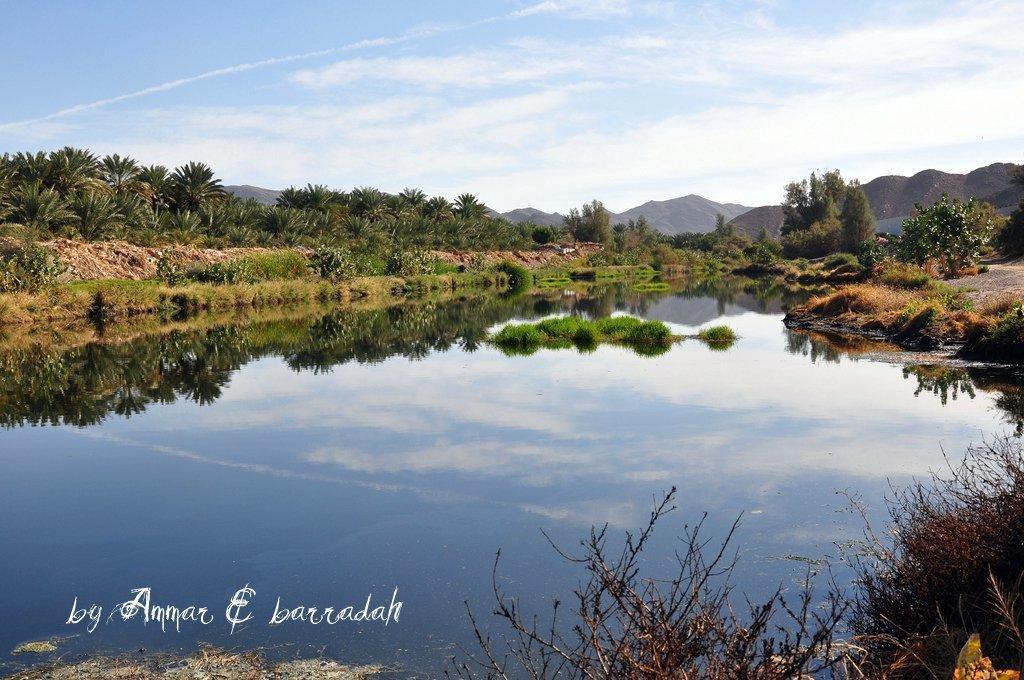How would you summarize this image in a sentence or two? There is water. Also there are many plants. In the back there are trees, hills and sky with clouds. In the left bottom corner there is a watermark. 